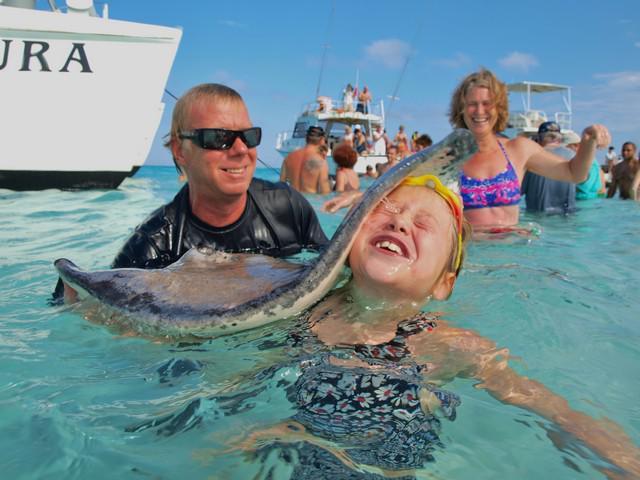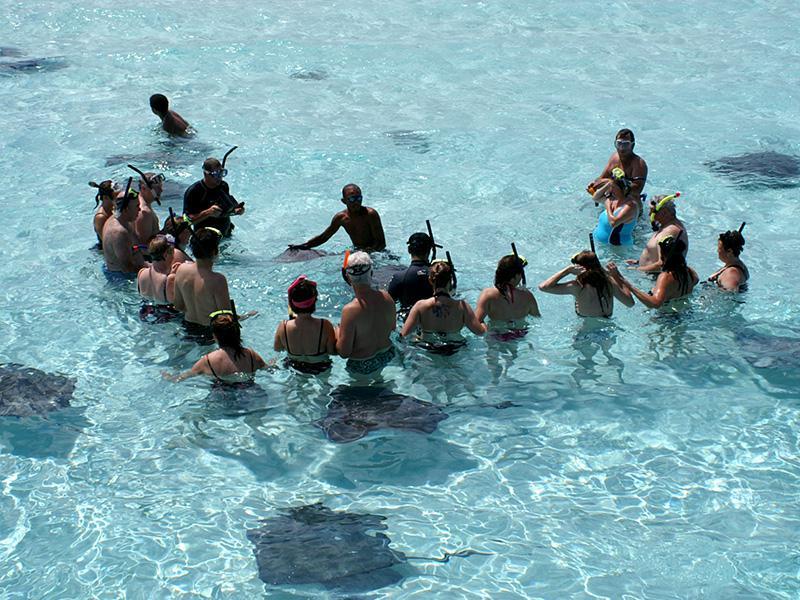The first image is the image on the left, the second image is the image on the right. Examine the images to the left and right. Is the description "The left image includes multiple people in the foreground, including a person with a stingray over part of their face." accurate? Answer yes or no. Yes. 